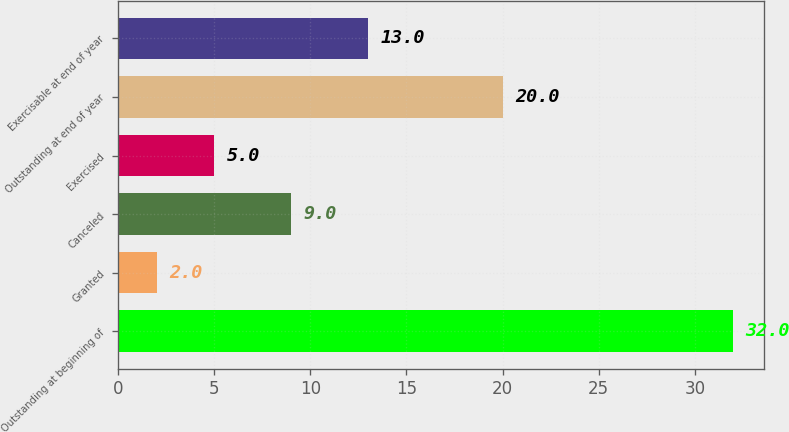Convert chart to OTSL. <chart><loc_0><loc_0><loc_500><loc_500><bar_chart><fcel>Outstanding at beginning of<fcel>Granted<fcel>Canceled<fcel>Exercised<fcel>Outstanding at end of year<fcel>Exercisable at end of year<nl><fcel>32<fcel>2<fcel>9<fcel>5<fcel>20<fcel>13<nl></chart> 